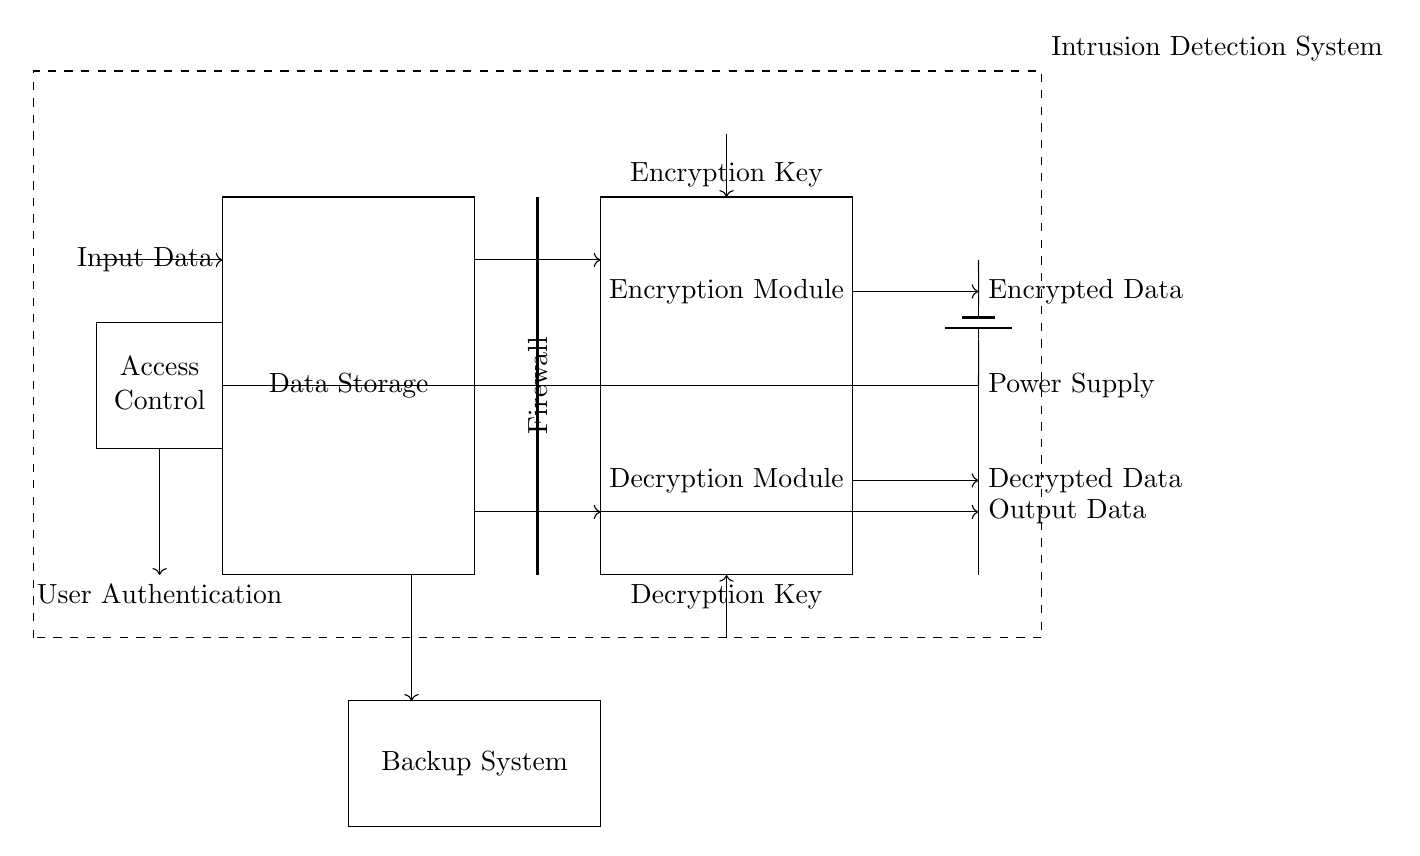What is the main function of the data storage unit? The main function of the data storage unit is to hold and manage the data securely. It is represented as a rectangle in the circuit.
Answer: Data Storage What connects the data storage unit to the encryption module? The connection between the data storage unit and the encryption module is denoted by an arrow, indicating the flow of data from the storage unit into the encryption module.
Answer: Arrow What type of module is included for ensuring access control? The module ensuring access control is labeled as an "Access Control" module. This is explicitly shown within a rectangle to indicate its importance in the circuit.
Answer: Access Control How many main modules are present in the circuit? To determine the number of main modules, we count the distinct labeled rectangles: Data Storage, Encryption Module, Decryption Module, and Access Control are four modules in total.
Answer: Four What does the firewall do in this circuit? The firewall acts as a security layer that helps block unauthorized access to the data flow between the different modules, indicating its role in protecting the system.
Answer: Security layer What type of system is drawn at the boundaries of the circuit? The dashed rectangle surrounding the circuit diagram is labeled as the "Intrusion Detection System," indicating that it serves as a security measure against potential breaches.
Answer: Intrusion Detection System What input does the encryption module require? The encryption module requires an "Encryption Key" input, which is indicated by an arrow pointing downward from above the module toward it.
Answer: Encryption Key 